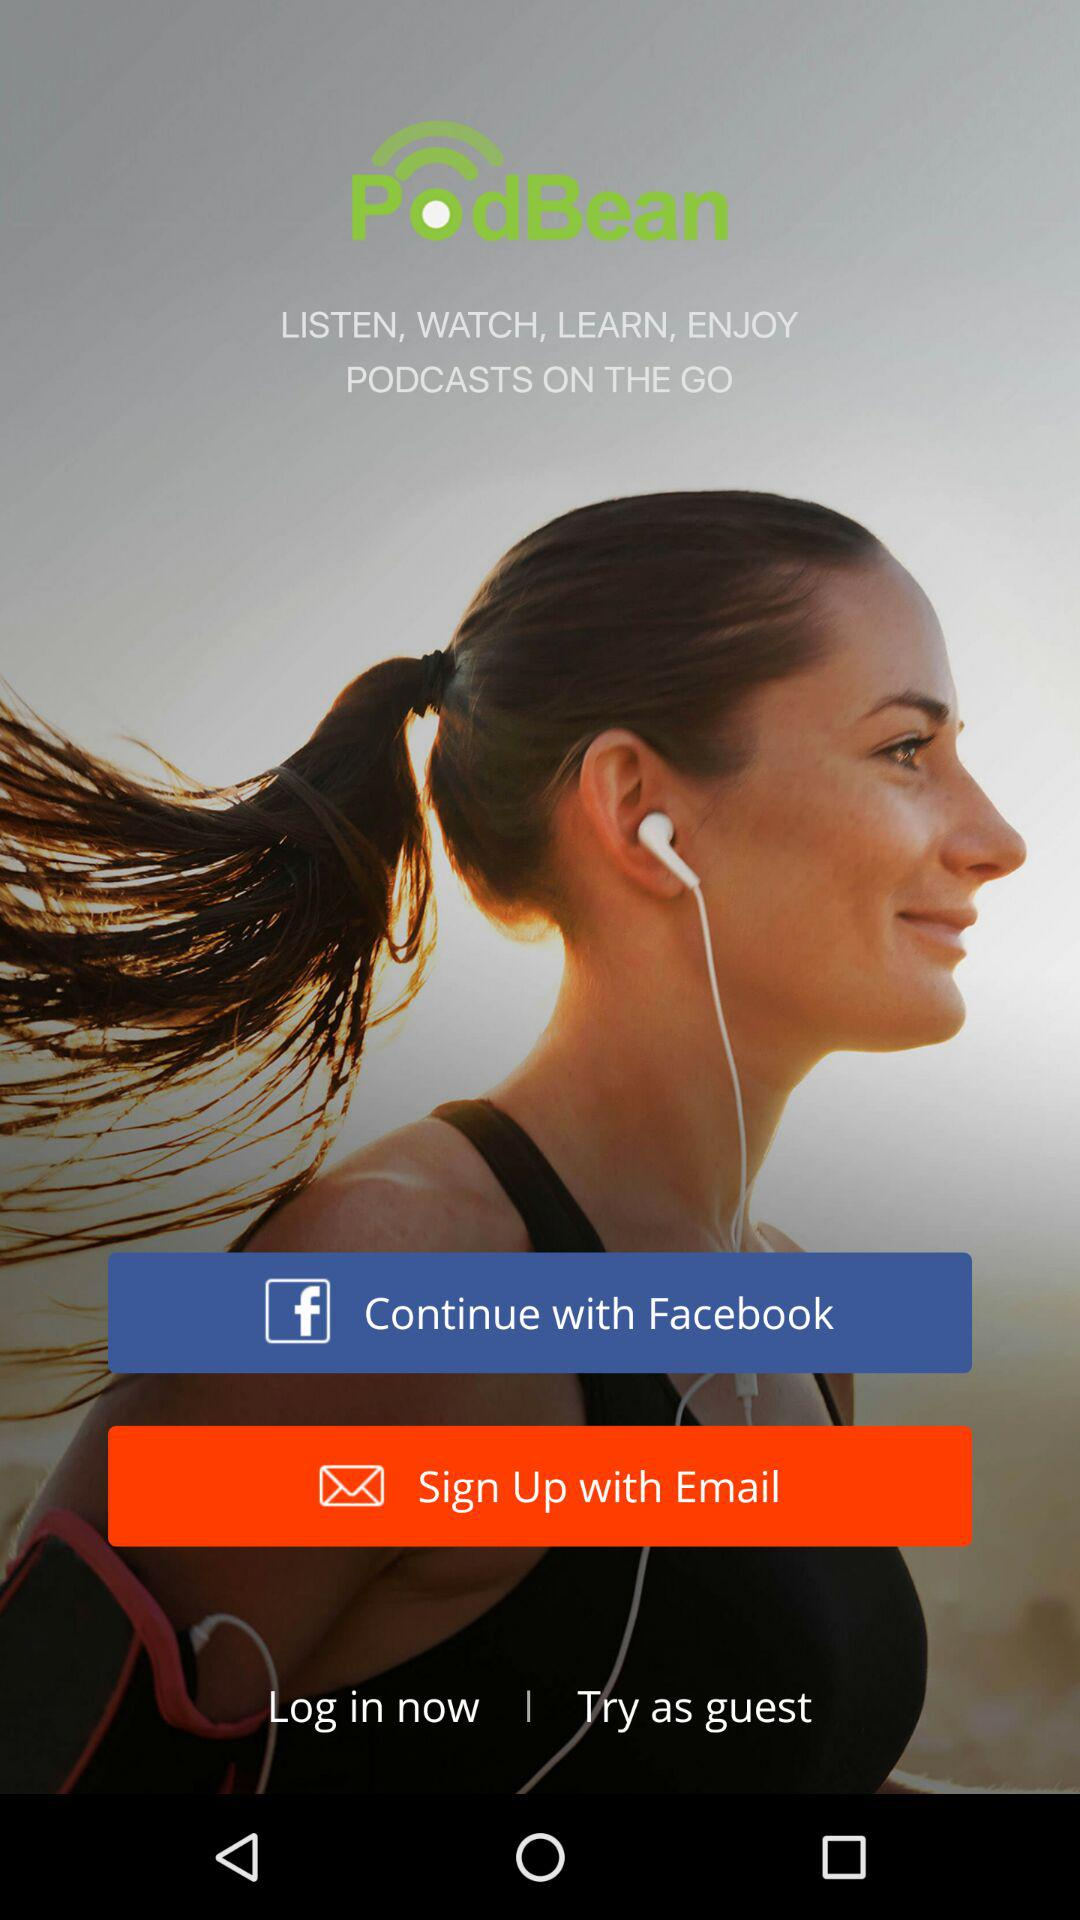What is the application name? The application name is "PodBean". 